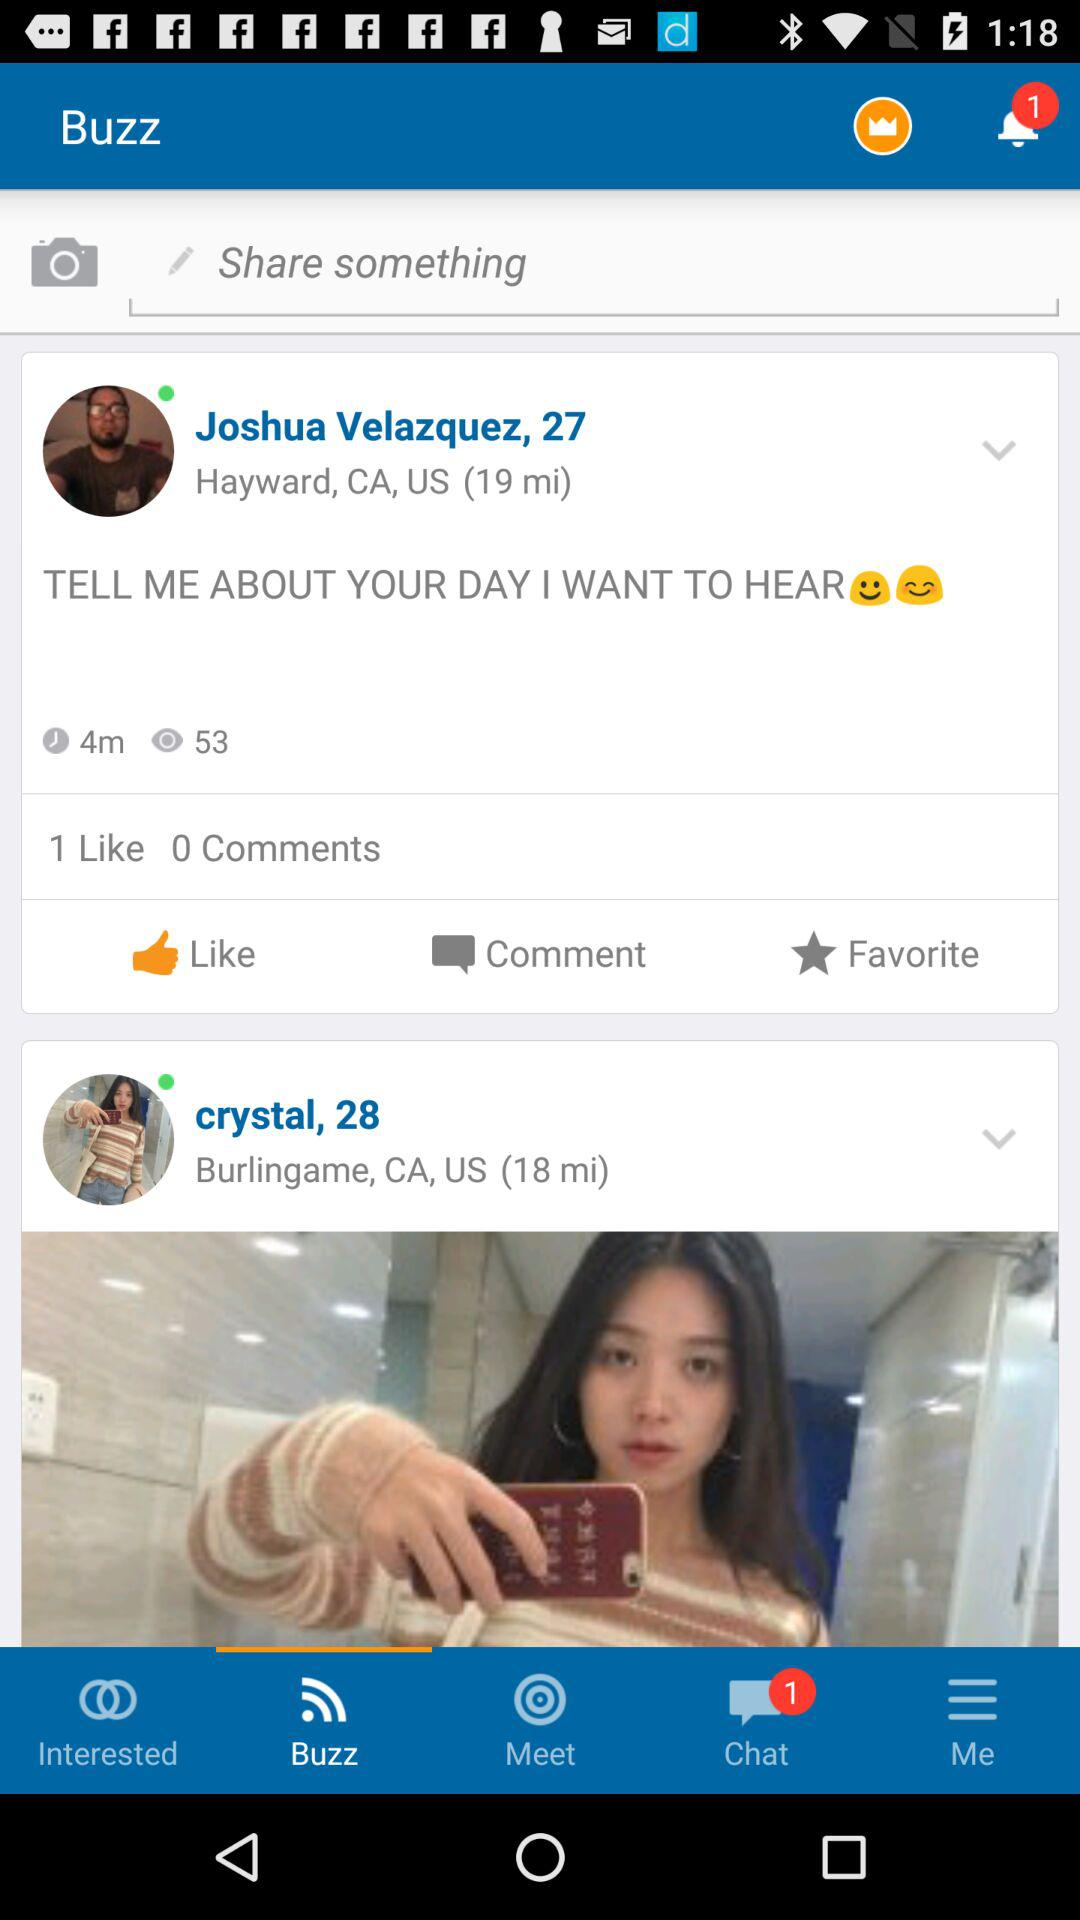How many likes were on Joshua Velazquez's post? There was 1 like. 